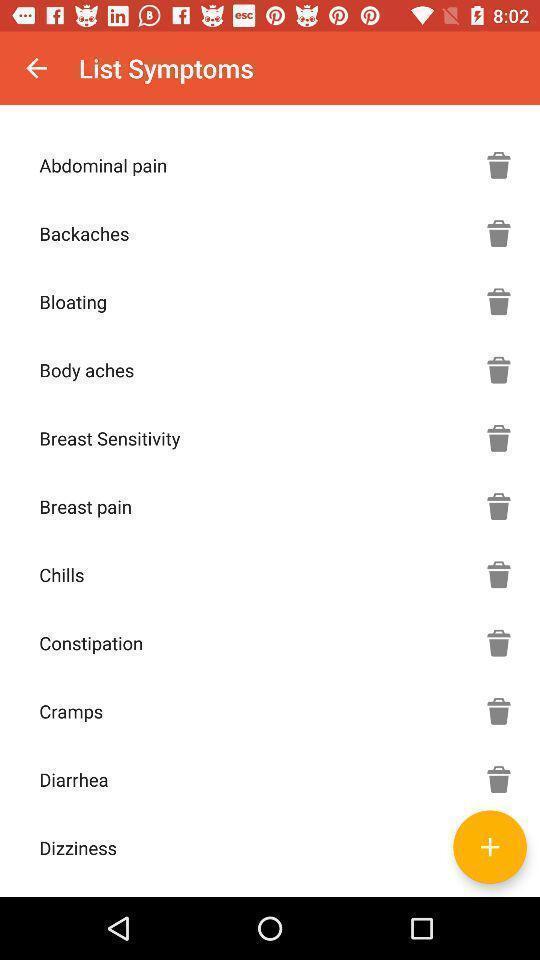Provide a description of this screenshot. Screen displaying a list of symptom names. 